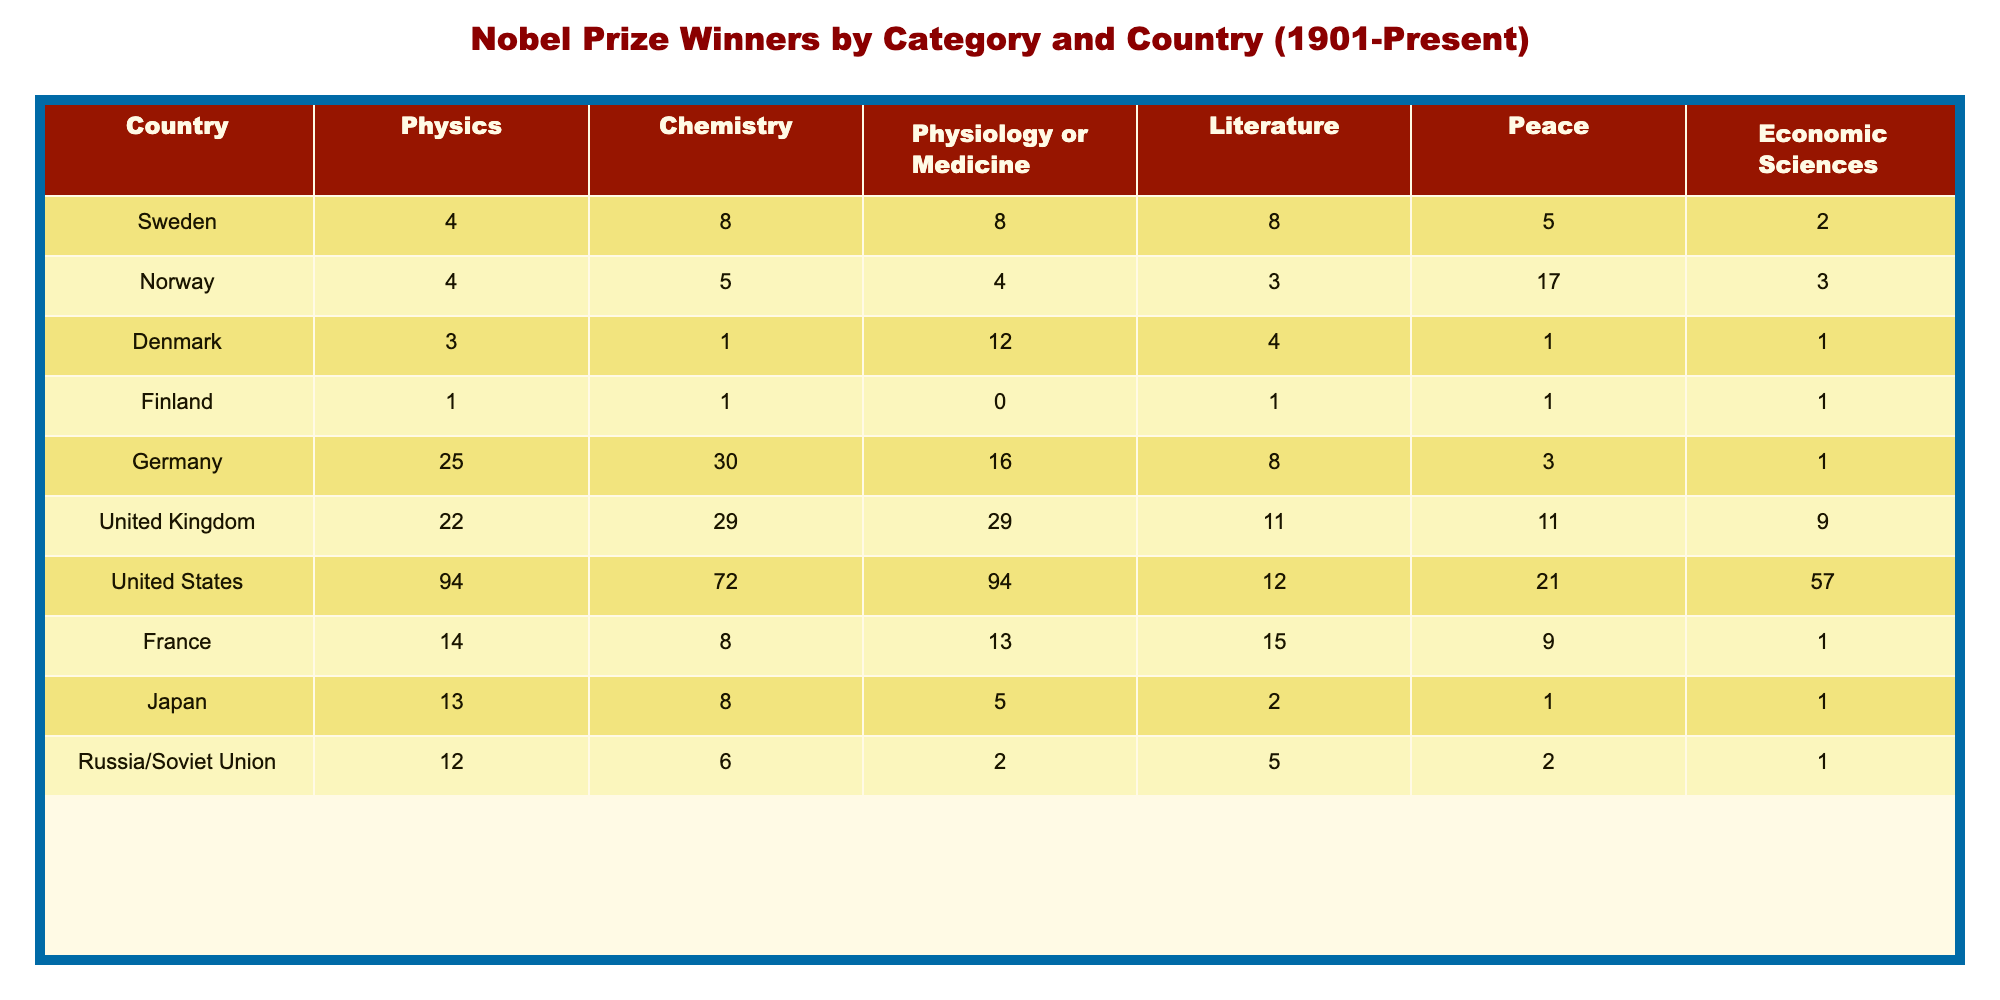What is the total number of Nobel Prize winners from Sweden across all categories? To find the total number of winners from Sweden, we sum the values in the Swedish column: 4 (Physics) + 8 (Chemistry) + 8 (Physiology or Medicine) + 8 (Literature) + 5 (Peace) + 2 (Economic Sciences) = 35.
Answer: 35 Which country has the highest number of Nobel Prize winners in the category of Physics? By examining the Physics row, we see that the United States has the highest number of winners with 94.
Answer: United States What is the difference in the number of winners in the Chemistry category between Germany and the United Kingdom? We find the number of winners for Germany (30) and for the United Kingdom (29) in the Chemistry row. The difference is 30 - 29 = 1.
Answer: 1 Is it true that Japan has won more Nobel Prizes in Literature than Sweden? Looking at the Literature row, Japan has 2 winners while Sweden has 8. Therefore, it is not true that Japan has more.
Answer: No What is the average number of Nobel Prize winners in the category of Peace across all countries listed? We sum the winners in the Peace category: 5 (Sweden) + 17 (Norway) + 1 (Denmark) + 1 (Finland) + 3 (Germany) + 11 (United Kingdom) + 21 (United States) + 9 (France) + 1 (Japan) + 2 (Russia/Soviet Union) = 70. There are 10 countries, so the average is 70/10 = 7.
Answer: 7 Which category has the least number of Nobel Prize winners from Denmark? By examining the rows for Denmark, we find that the category with the least number of winners is Chemistry with only 1.
Answer: Chemistry What country has the second highest number of winners in the Physiology or Medicine category? In the Physiology or Medicine row, the United States has the highest with 94, while Germany is second with 16.
Answer: Germany How many Nobel Prize winners has the United States had in total across all categories? Summing the winners from the United States across all categories: 94 (Physics) + 72 (Chemistry) + 94 (Physiology or Medicine) + 12 (Literature) + 21 (Peace) + 57 (Economic Sciences) = 350.
Answer: 350 Which country has the lowest number of Nobel Prize winners in the Economics category? In the Economic Sciences row, the countries with the lowest number of winners (tied) are Denmark, Finland, and Germany, each with 1 winner.
Answer: Denmark, Finland, Germany What is the ratio of Nobel Prize winners in Literature from Sweden to those from France? For Literature, Sweden has 8 winners and France has 15 winners. The ratio is 8:15.
Answer: 8:15 